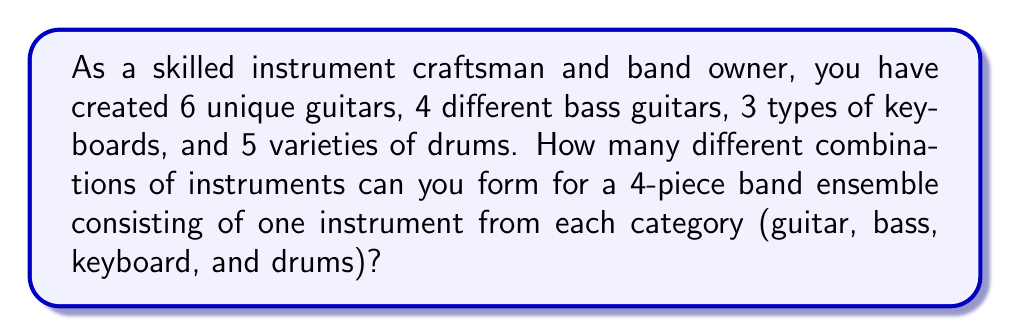Show me your answer to this math problem. Let's approach this step-by-step using the multiplication principle of combinatorics:

1) For the guitar position, we have 6 choices.
2) For the bass guitar position, we have 4 choices.
3) For the keyboard position, we have 3 choices.
4) For the drums position, we have 5 choices.

Since we need to choose one instrument from each category, and the choice of one instrument doesn't affect the choices for the other positions, we multiply these numbers together:

$$ \text{Total combinations} = 6 \times 4 \times 3 \times 5 $$

$$ = 360 $$

This calculation gives us the total number of unique ways to form a 4-piece band ensemble using one instrument from each category.
Answer: 360 